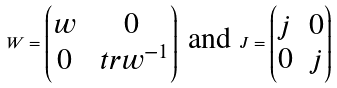Convert formula to latex. <formula><loc_0><loc_0><loc_500><loc_500>W = \left ( \begin{matrix} w & 0 \\ 0 & \ t r { w } ^ { - 1 } \end{matrix} \right ) \text { and } J = \left ( \begin{matrix} j & 0 \\ 0 & j \end{matrix} \right )</formula> 